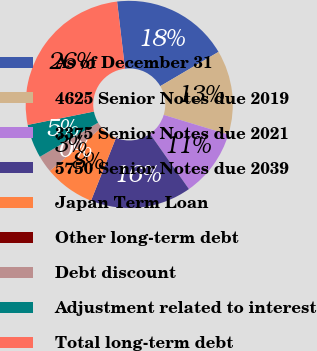Convert chart. <chart><loc_0><loc_0><loc_500><loc_500><pie_chart><fcel>As of December 31<fcel>4625 Senior Notes due 2019<fcel>3375 Senior Notes due 2021<fcel>5750 Senior Notes due 2039<fcel>Japan Term Loan<fcel>Other long-term debt<fcel>Debt discount<fcel>Adjustment related to interest<fcel>Total long-term debt<nl><fcel>18.41%<fcel>13.16%<fcel>10.53%<fcel>15.79%<fcel>7.9%<fcel>0.01%<fcel>2.64%<fcel>5.27%<fcel>26.3%<nl></chart> 